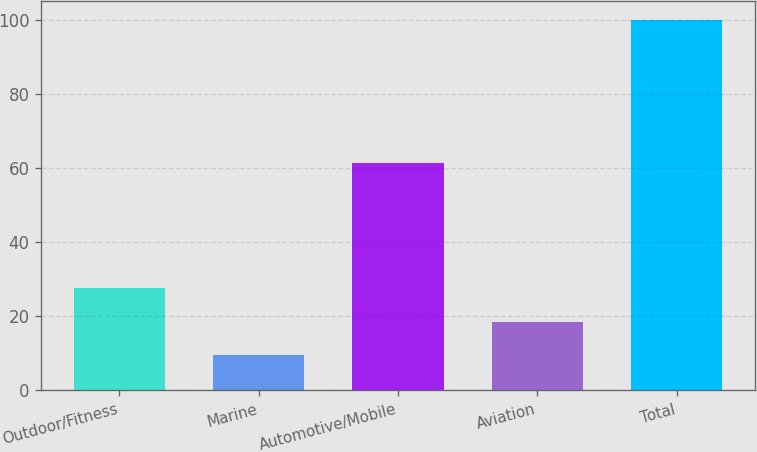<chart> <loc_0><loc_0><loc_500><loc_500><bar_chart><fcel>Outdoor/Fitness<fcel>Marine<fcel>Automotive/Mobile<fcel>Aviation<fcel>Total<nl><fcel>27.52<fcel>9.4<fcel>61.4<fcel>18.46<fcel>100<nl></chart> 